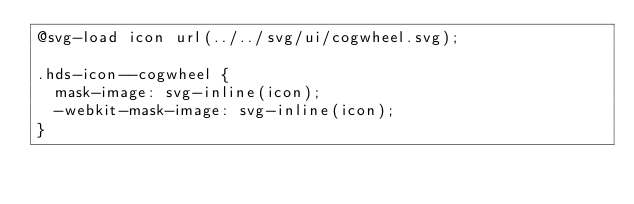Convert code to text. <code><loc_0><loc_0><loc_500><loc_500><_CSS_>@svg-load icon url(../../svg/ui/cogwheel.svg);

.hds-icon--cogwheel {
  mask-image: svg-inline(icon);
  -webkit-mask-image: svg-inline(icon);
}
</code> 